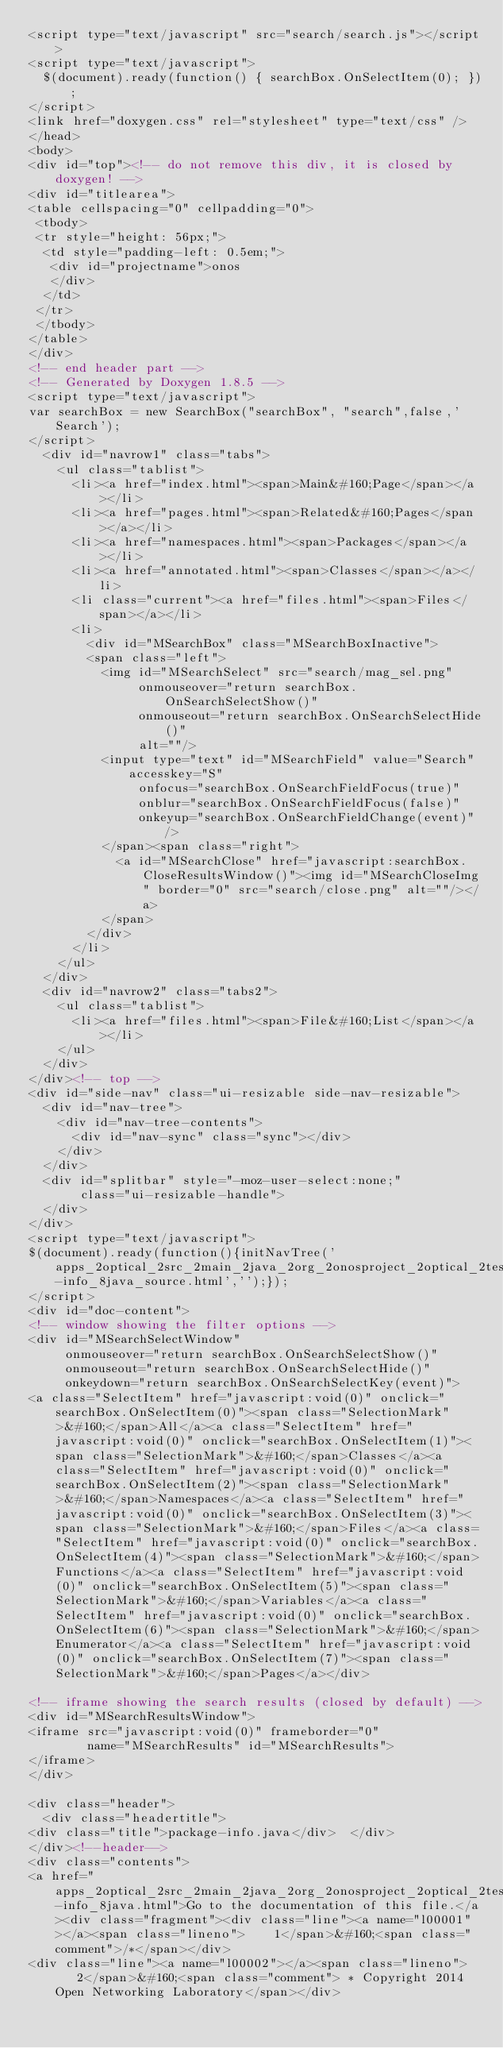Convert code to text. <code><loc_0><loc_0><loc_500><loc_500><_HTML_><script type="text/javascript" src="search/search.js"></script>
<script type="text/javascript">
  $(document).ready(function() { searchBox.OnSelectItem(0); });
</script>
<link href="doxygen.css" rel="stylesheet" type="text/css" />
</head>
<body>
<div id="top"><!-- do not remove this div, it is closed by doxygen! -->
<div id="titlearea">
<table cellspacing="0" cellpadding="0">
 <tbody>
 <tr style="height: 56px;">
  <td style="padding-left: 0.5em;">
   <div id="projectname">onos
   </div>
  </td>
 </tr>
 </tbody>
</table>
</div>
<!-- end header part -->
<!-- Generated by Doxygen 1.8.5 -->
<script type="text/javascript">
var searchBox = new SearchBox("searchBox", "search",false,'Search');
</script>
  <div id="navrow1" class="tabs">
    <ul class="tablist">
      <li><a href="index.html"><span>Main&#160;Page</span></a></li>
      <li><a href="pages.html"><span>Related&#160;Pages</span></a></li>
      <li><a href="namespaces.html"><span>Packages</span></a></li>
      <li><a href="annotated.html"><span>Classes</span></a></li>
      <li class="current"><a href="files.html"><span>Files</span></a></li>
      <li>
        <div id="MSearchBox" class="MSearchBoxInactive">
        <span class="left">
          <img id="MSearchSelect" src="search/mag_sel.png"
               onmouseover="return searchBox.OnSearchSelectShow()"
               onmouseout="return searchBox.OnSearchSelectHide()"
               alt=""/>
          <input type="text" id="MSearchField" value="Search" accesskey="S"
               onfocus="searchBox.OnSearchFieldFocus(true)" 
               onblur="searchBox.OnSearchFieldFocus(false)" 
               onkeyup="searchBox.OnSearchFieldChange(event)"/>
          </span><span class="right">
            <a id="MSearchClose" href="javascript:searchBox.CloseResultsWindow()"><img id="MSearchCloseImg" border="0" src="search/close.png" alt=""/></a>
          </span>
        </div>
      </li>
    </ul>
  </div>
  <div id="navrow2" class="tabs2">
    <ul class="tablist">
      <li><a href="files.html"><span>File&#160;List</span></a></li>
    </ul>
  </div>
</div><!-- top -->
<div id="side-nav" class="ui-resizable side-nav-resizable">
  <div id="nav-tree">
    <div id="nav-tree-contents">
      <div id="nav-sync" class="sync"></div>
    </div>
  </div>
  <div id="splitbar" style="-moz-user-select:none;" 
       class="ui-resizable-handle">
  </div>
</div>
<script type="text/javascript">
$(document).ready(function(){initNavTree('apps_2optical_2src_2main_2java_2org_2onosproject_2optical_2testapp_2package-info_8java_source.html','');});
</script>
<div id="doc-content">
<!-- window showing the filter options -->
<div id="MSearchSelectWindow"
     onmouseover="return searchBox.OnSearchSelectShow()"
     onmouseout="return searchBox.OnSearchSelectHide()"
     onkeydown="return searchBox.OnSearchSelectKey(event)">
<a class="SelectItem" href="javascript:void(0)" onclick="searchBox.OnSelectItem(0)"><span class="SelectionMark">&#160;</span>All</a><a class="SelectItem" href="javascript:void(0)" onclick="searchBox.OnSelectItem(1)"><span class="SelectionMark">&#160;</span>Classes</a><a class="SelectItem" href="javascript:void(0)" onclick="searchBox.OnSelectItem(2)"><span class="SelectionMark">&#160;</span>Namespaces</a><a class="SelectItem" href="javascript:void(0)" onclick="searchBox.OnSelectItem(3)"><span class="SelectionMark">&#160;</span>Files</a><a class="SelectItem" href="javascript:void(0)" onclick="searchBox.OnSelectItem(4)"><span class="SelectionMark">&#160;</span>Functions</a><a class="SelectItem" href="javascript:void(0)" onclick="searchBox.OnSelectItem(5)"><span class="SelectionMark">&#160;</span>Variables</a><a class="SelectItem" href="javascript:void(0)" onclick="searchBox.OnSelectItem(6)"><span class="SelectionMark">&#160;</span>Enumerator</a><a class="SelectItem" href="javascript:void(0)" onclick="searchBox.OnSelectItem(7)"><span class="SelectionMark">&#160;</span>Pages</a></div>

<!-- iframe showing the search results (closed by default) -->
<div id="MSearchResultsWindow">
<iframe src="javascript:void(0)" frameborder="0" 
        name="MSearchResults" id="MSearchResults">
</iframe>
</div>

<div class="header">
  <div class="headertitle">
<div class="title">package-info.java</div>  </div>
</div><!--header-->
<div class="contents">
<a href="apps_2optical_2src_2main_2java_2org_2onosproject_2optical_2testapp_2package-info_8java.html">Go to the documentation of this file.</a><div class="fragment"><div class="line"><a name="l00001"></a><span class="lineno">    1</span>&#160;<span class="comment">/*</span></div>
<div class="line"><a name="l00002"></a><span class="lineno">    2</span>&#160;<span class="comment"> * Copyright 2014 Open Networking Laboratory</span></div></code> 